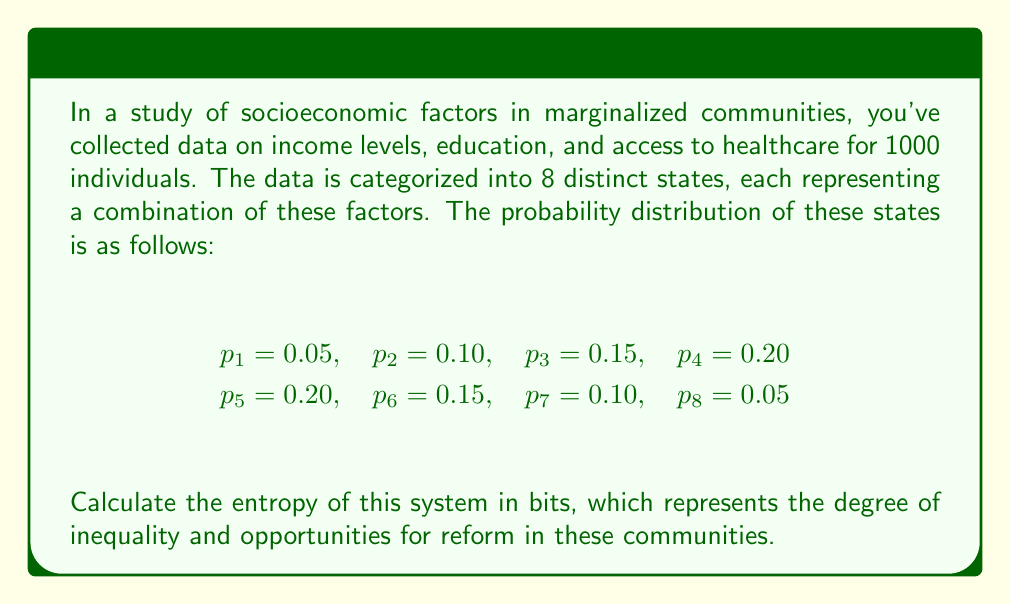Provide a solution to this math problem. To solve this problem, we'll use the entropy formula from statistical mechanics, adapted for discrete probability distributions:

$$S = -k \sum_{i=1}^{n} p_i \log_2(p_i)$$

Where:
- $S$ is the entropy
- $k$ is Boltzmann's constant (in this case, we'll use $k=1$ as we're calculating in bits)
- $p_i$ is the probability of each state
- $n$ is the number of states (in this case, 8)

Let's calculate each term:

1. $-0.05 \log_2(0.05) = 0.2161$
2. $-0.10 \log_2(0.10) = 0.3322$
3. $-0.15 \log_2(0.15) = 0.4105$
4. $-0.20 \log_2(0.20) = 0.4644$
5. $-0.20 \log_2(0.20) = 0.4644$
6. $-0.15 \log_2(0.15) = 0.4105$
7. $-0.10 \log_2(0.10) = 0.3322$
8. $-0.05 \log_2(0.05) = 0.2161$

Now, we sum all these terms:

$$S = 0.2161 + 0.3322 + 0.4105 + 0.4644 + 0.4644 + 0.4105 + 0.3322 + 0.2161$$

$$S = 2.8464$$

This value represents the entropy of the system in bits, indicating the degree of inequality and potential for reform in these communities.
Answer: 2.8464 bits 